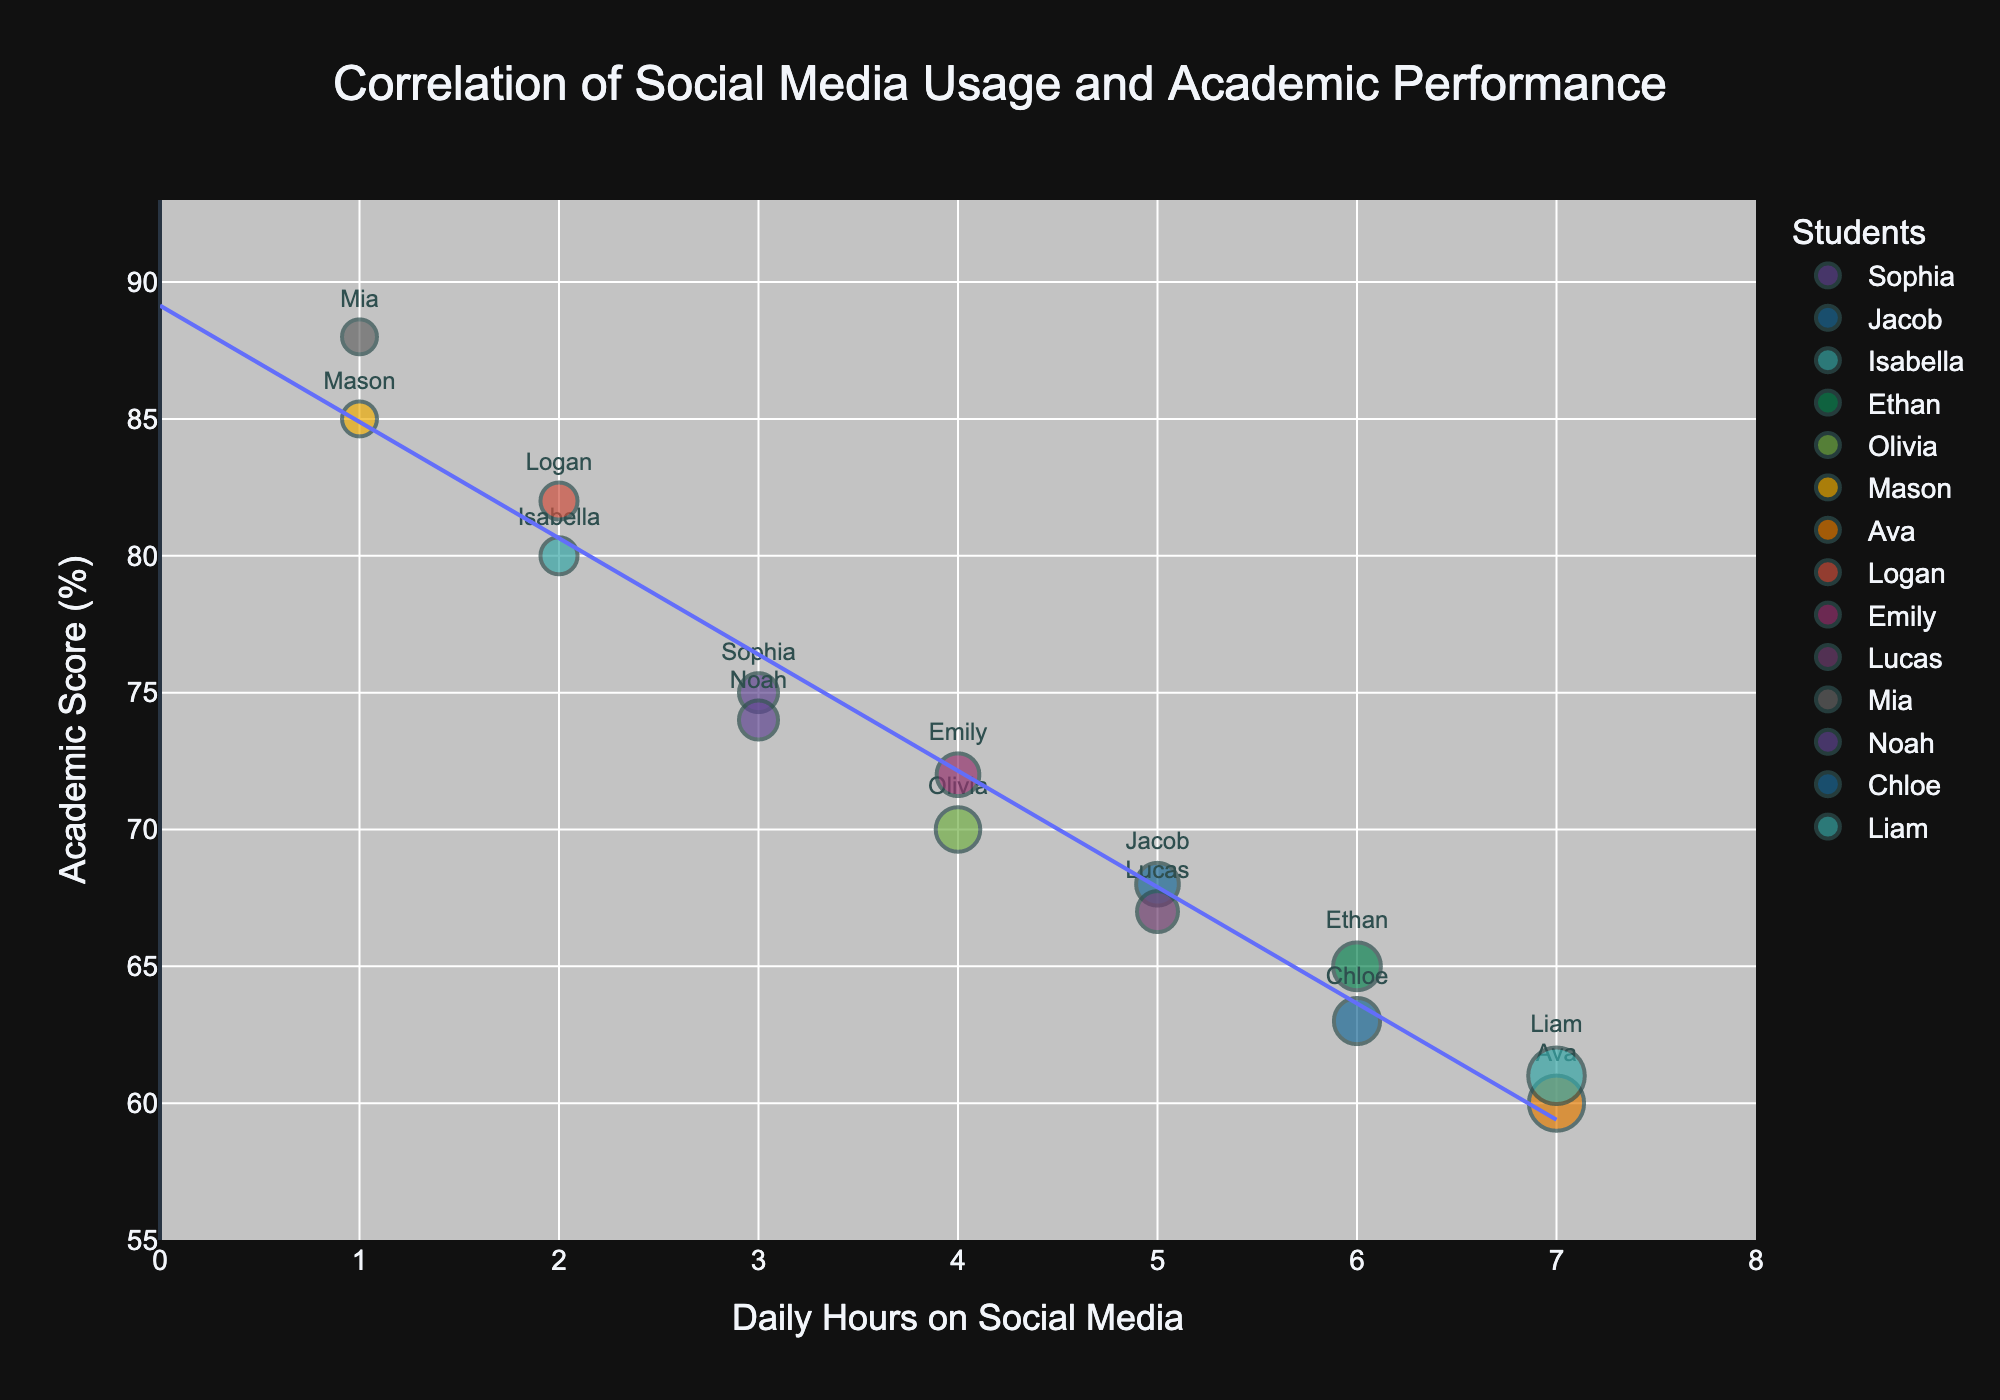What is the title of the bubble chart? The title of the chart is usually displayed prominently at the top. Look at the top of the figure for a large and clear text.
Answer: Correlation of Social Media Usage and Academic Performance How many hours does Ava spend on social media daily? Find the bubble labeled "Ava" and check its position on the x-axis, which represents daily hours on social media.
Answer: 7 Which student has the highest academic score? Locate the highest point on the y-axis, which indicates academic scores, and identify the corresponding student.
Answer: Mia Who spends 5 hours on social media daily and what is their academic score? Identify the bubbles positioned at 5 hours on the x-axis and then check the y-axis value for each.
Answer: Jacob has an academic score of 68, Lucas has an academic score of 67 What is the trend between social media usage and academic performance? The trend is provided by the trend line added to the figure. Observe if it slopes upward or downward.
Answer: Downward Compare the academic scores of Isla and Logan. Locate the bubbles for Isla and Logan; then check their positions on the y-axis.
Answer: Logan has a higher score (82) than Isla (80) Which students spend more than 5 hours on social media and what are their academic scores? Look at the bubbles positioned beyond the 5-hour mark on the x-axis, then read their corresponding y-axis values.
Answer: Ethan (65), Ava (60), Chloe (63), Liam (61) What is the average academic score of students who spend 3 hours on social media daily? Locate the bubbles for students who spend 3 hours on the x-axis. Sum their academic scores and divide by the number of students. The scores are 75 (Sophia) and 74 (Noah). Hence, (75 + 74) / 2 = 74.5.
Answer: 74.5 What is the average daily social media usage among students? Sum the daily hours on social media for all students and divide by the number of students. The total hours are 52, and there are 14 students. Hence, 52 / 14 ≈ 3.71 hours.
Answer: 3.71 hours Which student has the largest bubble size and what does it represent? Identify the bubble that appears the largest in size and check the legend or hover text for its representation.
Answer: Liam, it represents his engagement level 